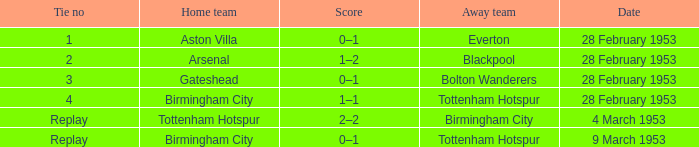Which home team holds a 0-1 score, and an away team of tottenham hotspur? Birmingham City. 